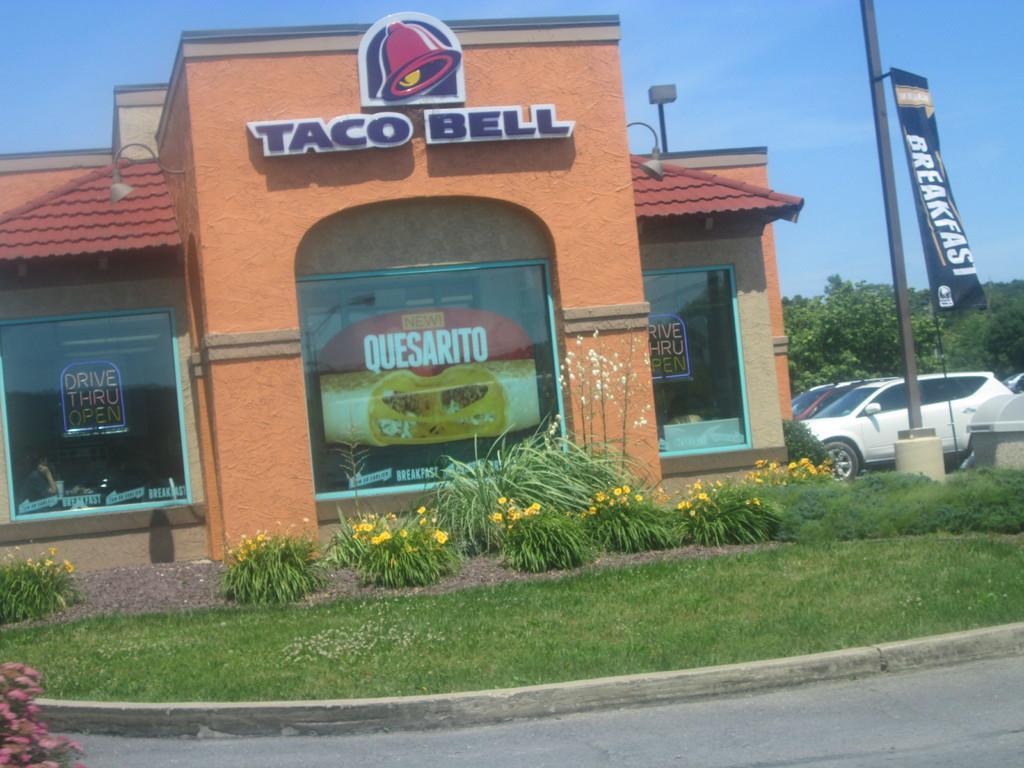In one or two sentences, can you explain what this image depicts? In this picture there is a building and there is text and there are lights on the wall and there are posters and there is text on the posters. On the right side of the image there are vehicles and there is a flag and there is a pole and there are trees. At the top there is sky. At the bottom there are flowers and plants and there is grass. 